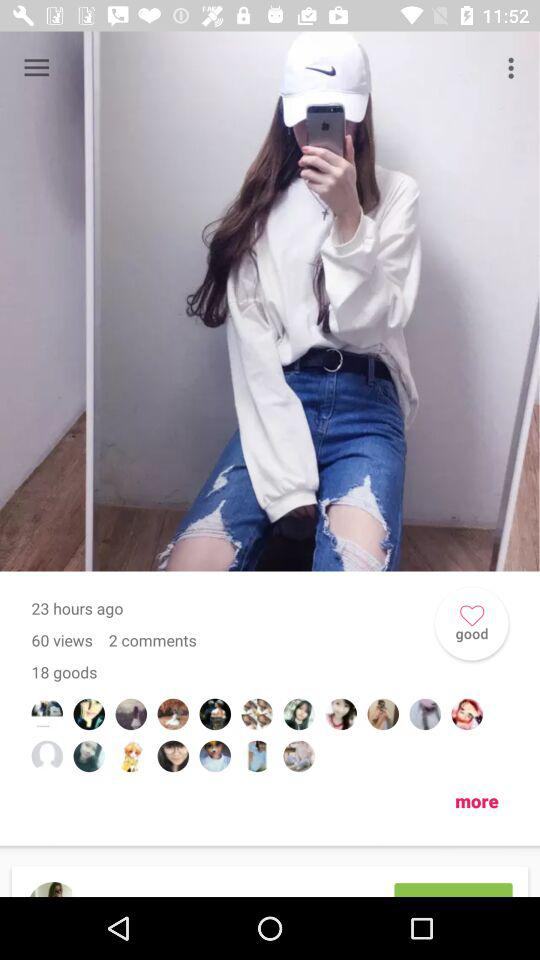How many "goods" have been received? The number of "goods" received is 18. 